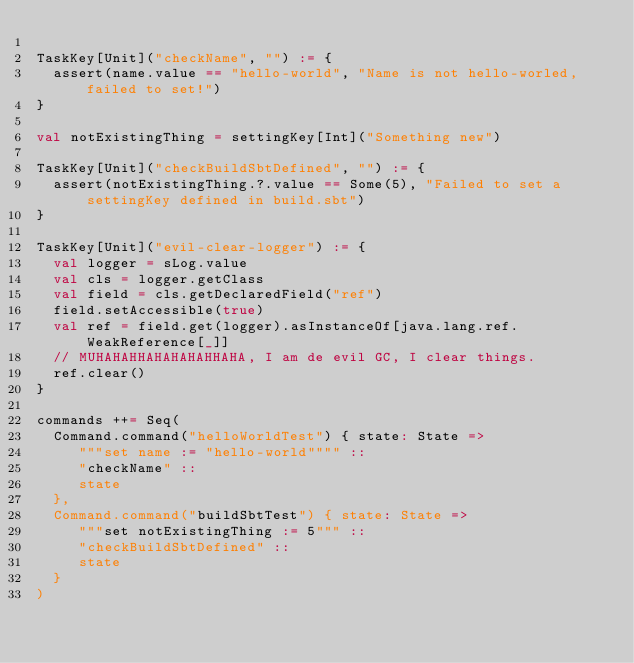Convert code to text. <code><loc_0><loc_0><loc_500><loc_500><_Scala_>
TaskKey[Unit]("checkName", "") := {
	assert(name.value == "hello-world", "Name is not hello-worled, failed to set!")
}

val notExistingThing = settingKey[Int]("Something new")

TaskKey[Unit]("checkBuildSbtDefined", "") := {
	assert(notExistingThing.?.value == Some(5), "Failed to set a settingKey defined in build.sbt")
}

TaskKey[Unit]("evil-clear-logger") := {
  val logger = sLog.value
  val cls = logger.getClass
  val field = cls.getDeclaredField("ref")
  field.setAccessible(true)
  val ref = field.get(logger).asInstanceOf[java.lang.ref.WeakReference[_]]
  // MUHAHAHHAHAHAHAHHAHA, I am de evil GC, I clear things.
  ref.clear()
}

commands ++= Seq(
  Command.command("helloWorldTest") { state: State =>
     """set name := "hello-world"""" ::
     "checkName" :: 
     state
  },
  Command.command("buildSbtTest") { state: State =>
     """set notExistingThing := 5""" ::
     "checkBuildSbtDefined" :: 
     state
  }
)</code> 